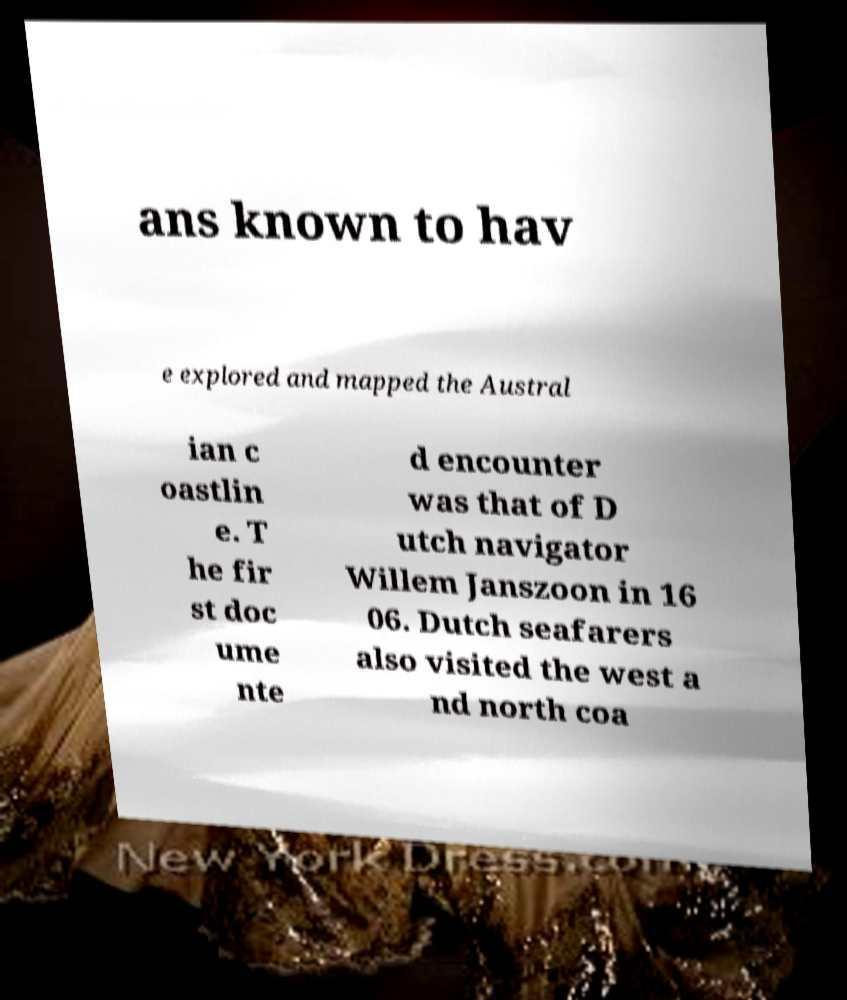I need the written content from this picture converted into text. Can you do that? ans known to hav e explored and mapped the Austral ian c oastlin e. T he fir st doc ume nte d encounter was that of D utch navigator Willem Janszoon in 16 06. Dutch seafarers also visited the west a nd north coa 